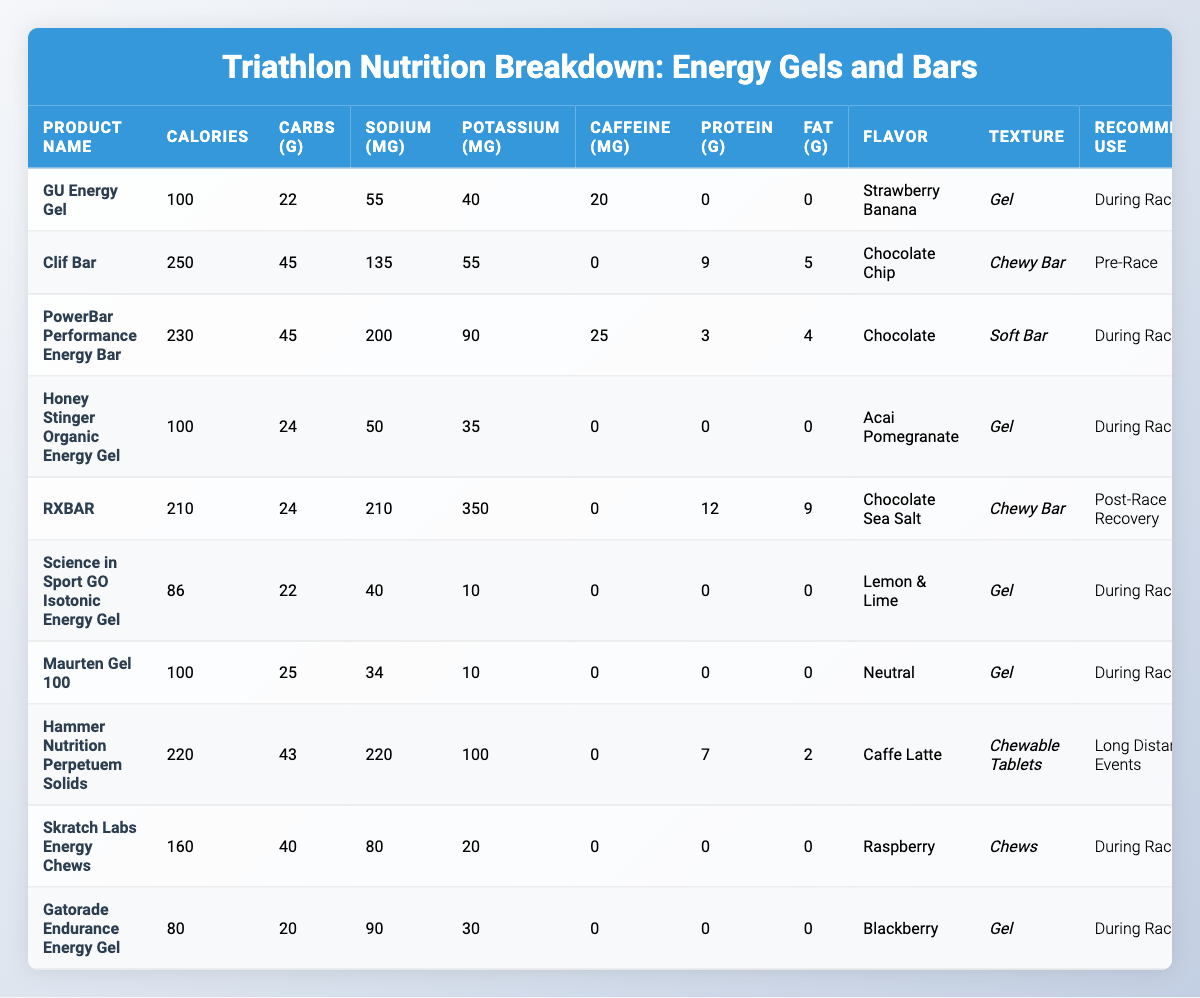What is the highest calorie energy gel or bar in the table? Looking at the "Calories" column, the highest value is 250, which corresponds to the "Clif Bar."
Answer: Clif Bar Which product has the lowest sodium content? By checking the "Sodium (mg)" column, the product with the lowest sodium content is the "Science in Sport GO Isotonic Energy Gel," with 40 mg.
Answer: Science in Sport GO Isotonic Energy Gel How many grams of carbohydrates does the Honey Stinger Organic Energy Gel contain? The "Carbohydrates (g)" column shows that it contains 24 grams.
Answer: 24 What is the average amount of protein across all products? The protein values are 0, 9, 3, 0, 12, 0, 0, 7, 0, and 0. The total is 31 grams, and dividing by 10 products gives an average of 3.1 grams.
Answer: 3.1 Which two products contain caffeine? Referring to the "Caffeine (mg)" column, the "GU Energy Gel" contains 20 mg of caffeine, and the "PowerBar Performance Energy Bar" contains 25 mg.
Answer: GU Energy Gel and PowerBar Performance Energy Bar What is the total amount of fat in all the products listed? Adding up the fat amounts: 0 + 5 + 4 + 0 + 9 + 0 + 0 + 2 + 0 + 0 totals to 20 grams of fat across all products.
Answer: 20 How many products have a recommended use of "During Race"? The "Recommended Use" column shows that seven products are recommended for use during the race.
Answer: 7 Is there any product that has both a high protein and fat content? The "RXBAR" has 12 grams of protein and 9 grams of fat, making it the only product with high values in both categories.
Answer: Yes Which product has the highest potassium content? Looking at the "Potassium (mg)" column, the "RXBAR" has the highest potassium content at 350 mg.
Answer: RXBAR What is the difference in carbohydrates between the product with the highest and lowest carbohydrates? The maximum carbohydrates are 45 g (Clif Bar and PowerBar) and the minimum is 20 g (Gatorade Endurance Energy Gel), so the difference is 45 - 20 = 25 grams.
Answer: 25 